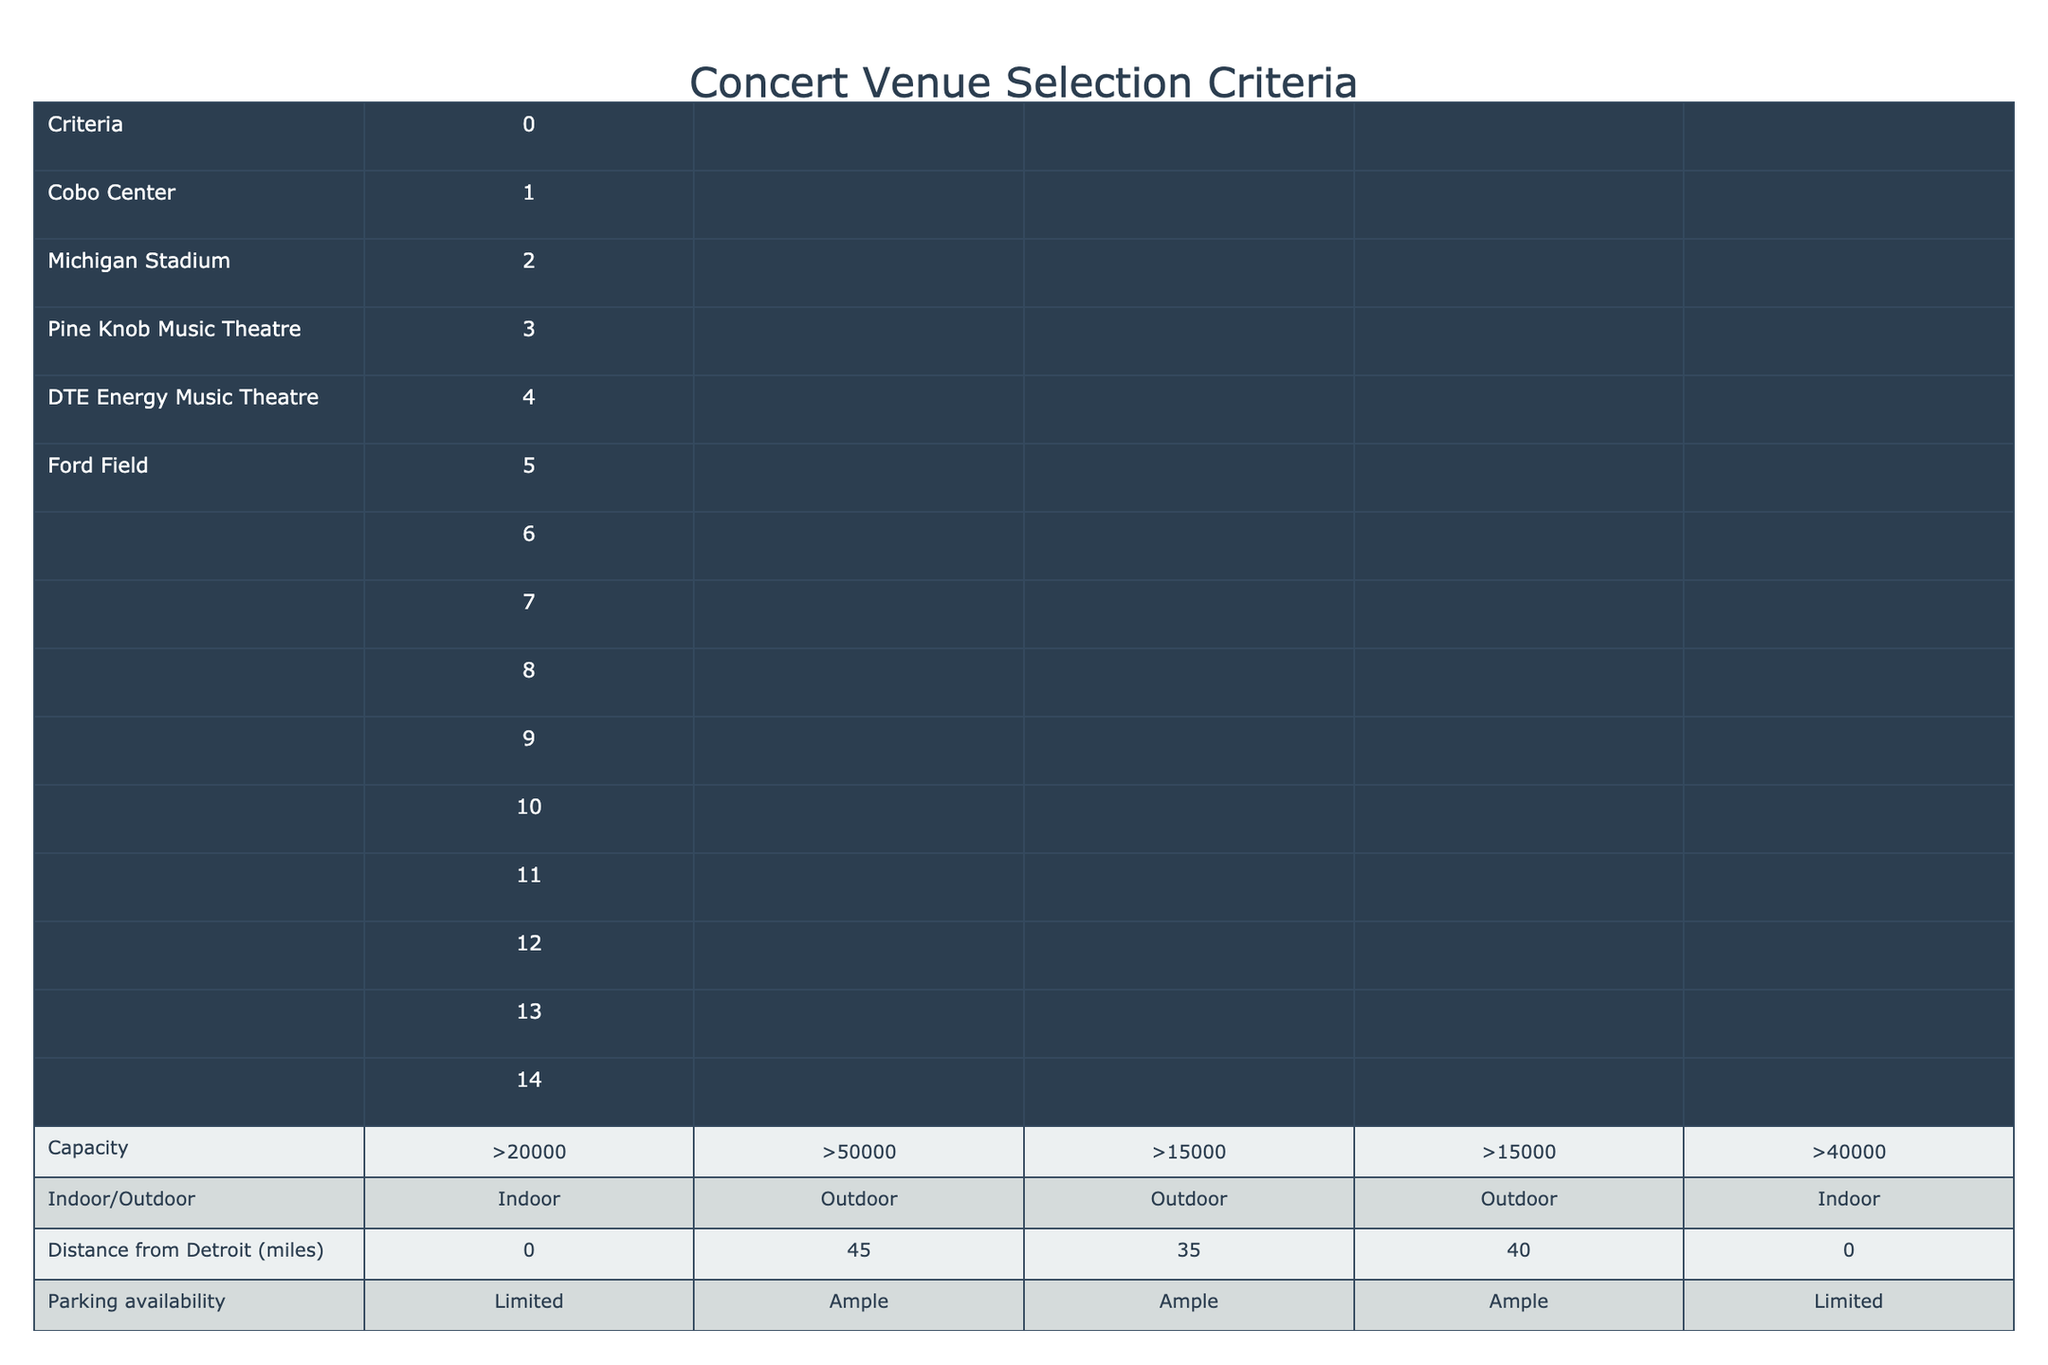What is the capacity of Pine Knob Music Theatre? The table provides a specific capacity for each venue. For Pine Knob Music Theatre, it states ">15000".
Answer: >15000 Which venue has the best public transport access? By comparing the public transport access ratings, Cobo Center and Ford Field both have "Excellent" access, while the other venues have "Good" or "Limited" access.
Answer: Cobo Center and Ford Field Is Michigan Stadium an indoor venue? The table specifies the type (indoor or outdoor) for each venue. Michigan Stadium is labeled as "Outdoor".
Answer: No What are the food and beverage options like at DTE Energy Music Theatre? The table lists food and beverage options for each venue, indicating that DTE Energy Music Theatre has "Very Good" options.
Answer: Very Good How many venues have a historical significance rating of "High"? The table can be scanned for the historical significance ratings, where Cobo Center, DTE Energy Music Theatre, and Ford Field have a "High" rating, giving us a total of three such venues.
Answer: 3 Which venue poses the lowest weather risk based on the scale? The weather risk ratings are listed from 1 to 10, with a lower number indicating less risk. Cobo Center and Ford Field both have a weather risk of 2, making them the venues with the lowest risk.
Answer: Cobo Center and Ford Field If we consider sound system quality, which venue has the lowest rating? Sound system quality ratings are indicated for each venue, and by comparing them, we see that Pine Knob Music Theatre has a rating of "Very Good," while others are rated "Good" or "Excellent." However, "Good" is the lowest rating overall, which applies to Cobo Center and others as well.
Answer: Cobo Center How far is Michigan Stadium from Detroit? The table provides the distance from Detroit for each venue, and for Michigan Stadium, it states "45 miles."
Answer: 45 miles What percentage of the venues have limited parking availability? The table shows that Cobo Center and Ford Field have "Limited" parking availability out of the five venues. To find the percentage, we take 2 limited venues out of 5 total, so (2/5)*100 = 40%.
Answer: 40% 